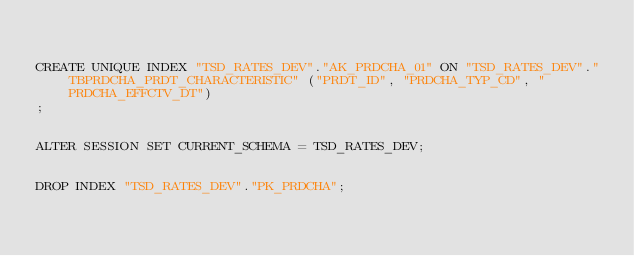Convert code to text. <code><loc_0><loc_0><loc_500><loc_500><_SQL_>

CREATE UNIQUE INDEX "TSD_RATES_DEV"."AK_PRDCHA_01" ON "TSD_RATES_DEV"."TBPRDCHA_PRDT_CHARACTERISTIC" ("PRDT_ID", "PRDCHA_TYP_CD", "PRDCHA_EFFCTV_DT")
;


ALTER SESSION SET CURRENT_SCHEMA = TSD_RATES_DEV;


DROP INDEX "TSD_RATES_DEV"."PK_PRDCHA";


</code> 